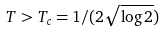<formula> <loc_0><loc_0><loc_500><loc_500>T > T _ { c } = 1 / ( 2 \sqrt { \log 2 } )</formula> 